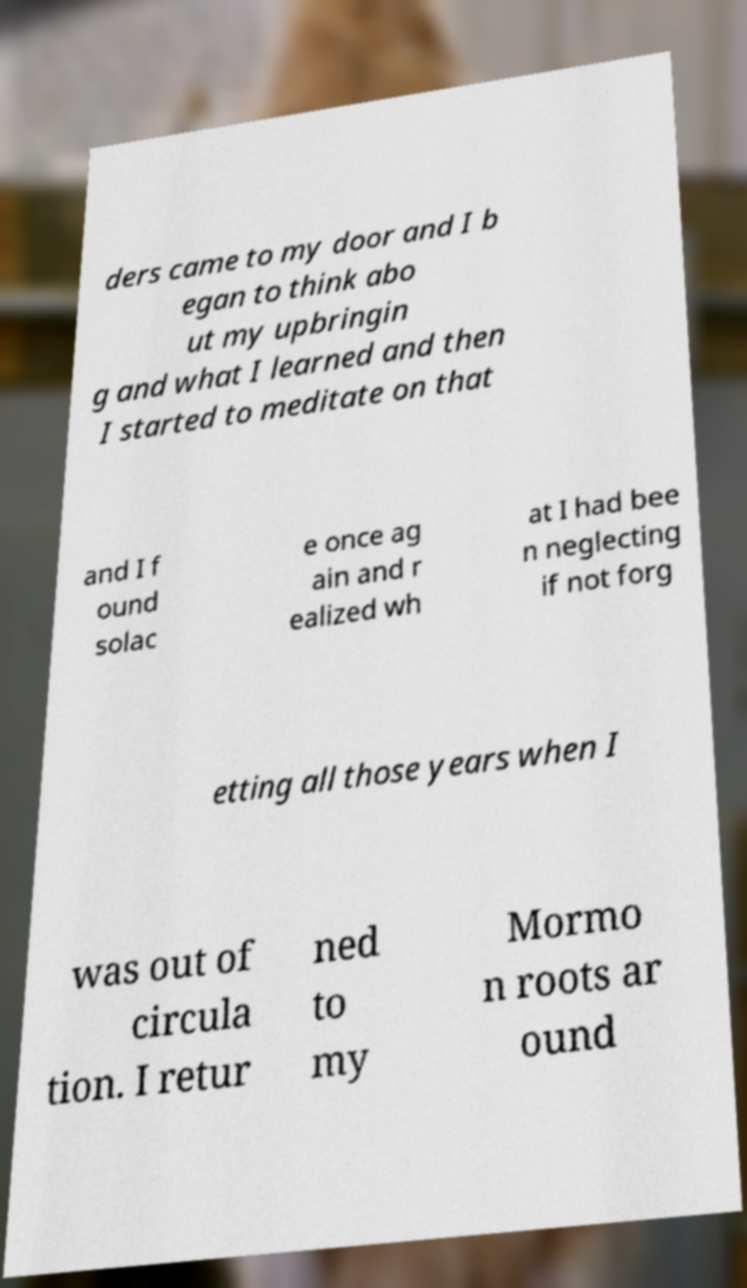Could you assist in decoding the text presented in this image and type it out clearly? ders came to my door and I b egan to think abo ut my upbringin g and what I learned and then I started to meditate on that and I f ound solac e once ag ain and r ealized wh at I had bee n neglecting if not forg etting all those years when I was out of circula tion. I retur ned to my Mormo n roots ar ound 